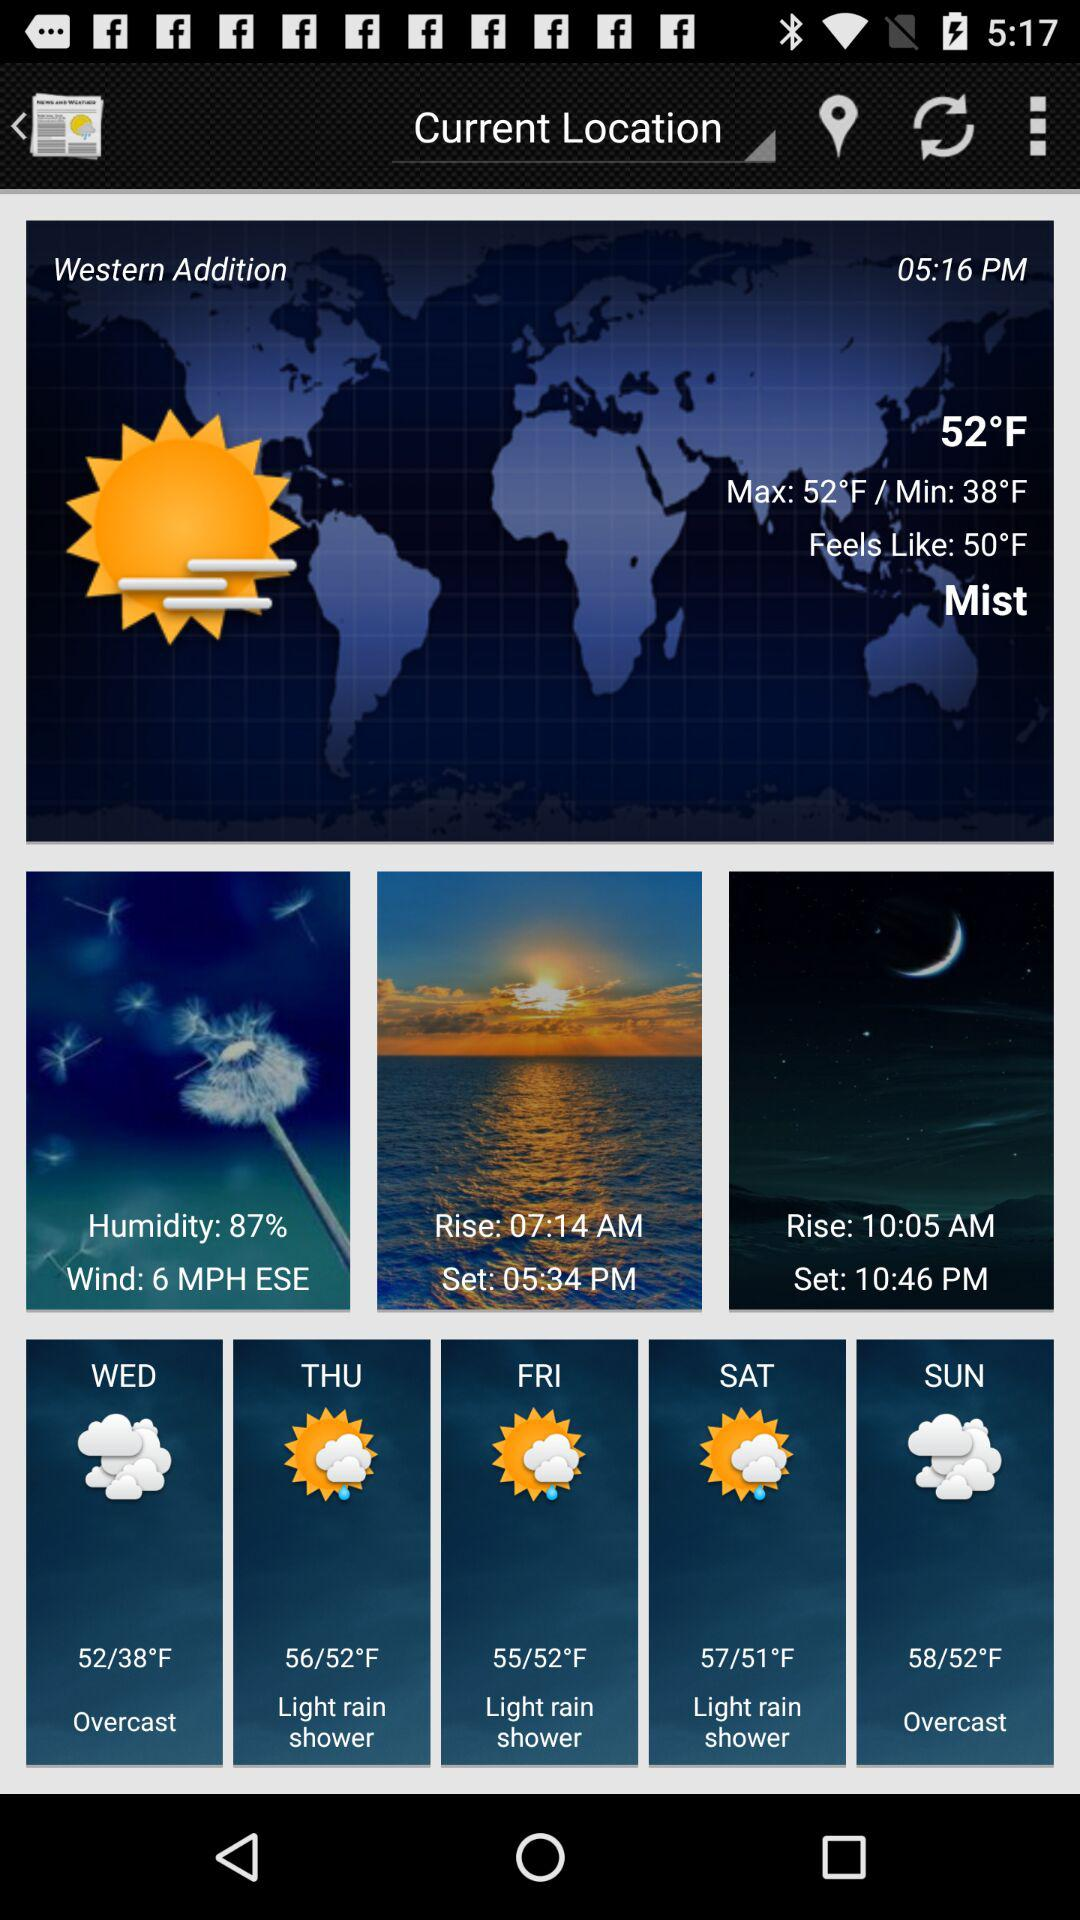What is the difference between the highest and lowest temperature for the day?
Answer the question using a single word or phrase. 14°F 